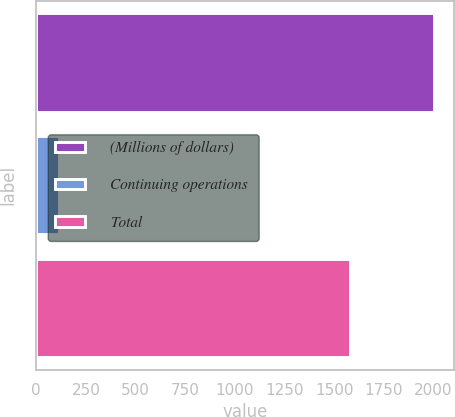Convert chart to OTSL. <chart><loc_0><loc_0><loc_500><loc_500><bar_chart><fcel>(Millions of dollars)<fcel>Continuing operations<fcel>Total<nl><fcel>2002<fcel>115<fcel>1580<nl></chart> 